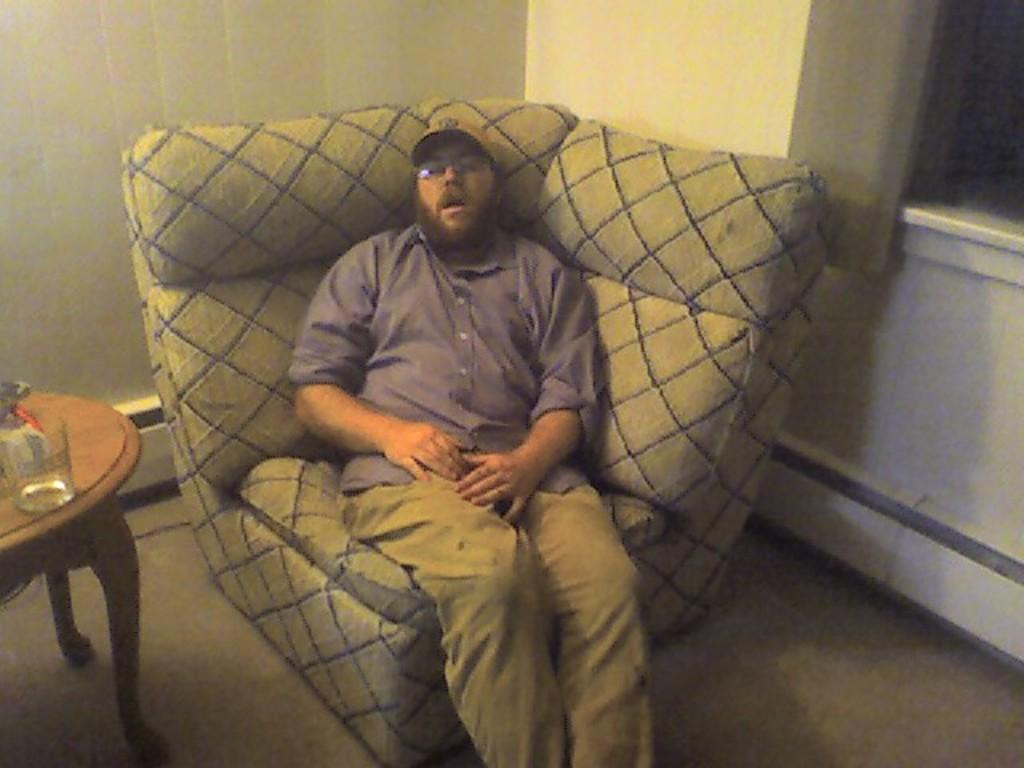Who is present in the image? There is a man in the image. What is the man doing in the image? The man is sitting on a sofa and sleeping. What is located behind the sofa? There is a table behind the sofa. What is placed on the table? A glass is placed on the table. What can be seen in the background of the image? There is a wall in the background of the image. What type of cord is being used to play volleyball in the image? There is no cord or volleyball present in the image. What decision is the man making while sitting on the sofa in the image? The man is sleeping, so there is no decision-making process visible in the image. 